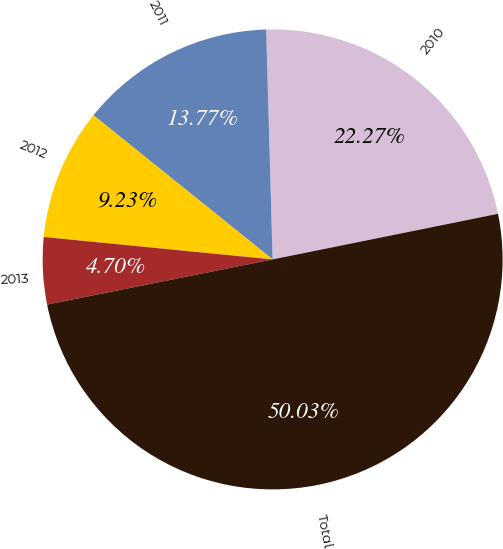<chart> <loc_0><loc_0><loc_500><loc_500><pie_chart><fcel>2010<fcel>2011<fcel>2012<fcel>2013<fcel>Total<nl><fcel>22.27%<fcel>13.77%<fcel>9.23%<fcel>4.7%<fcel>50.03%<nl></chart> 